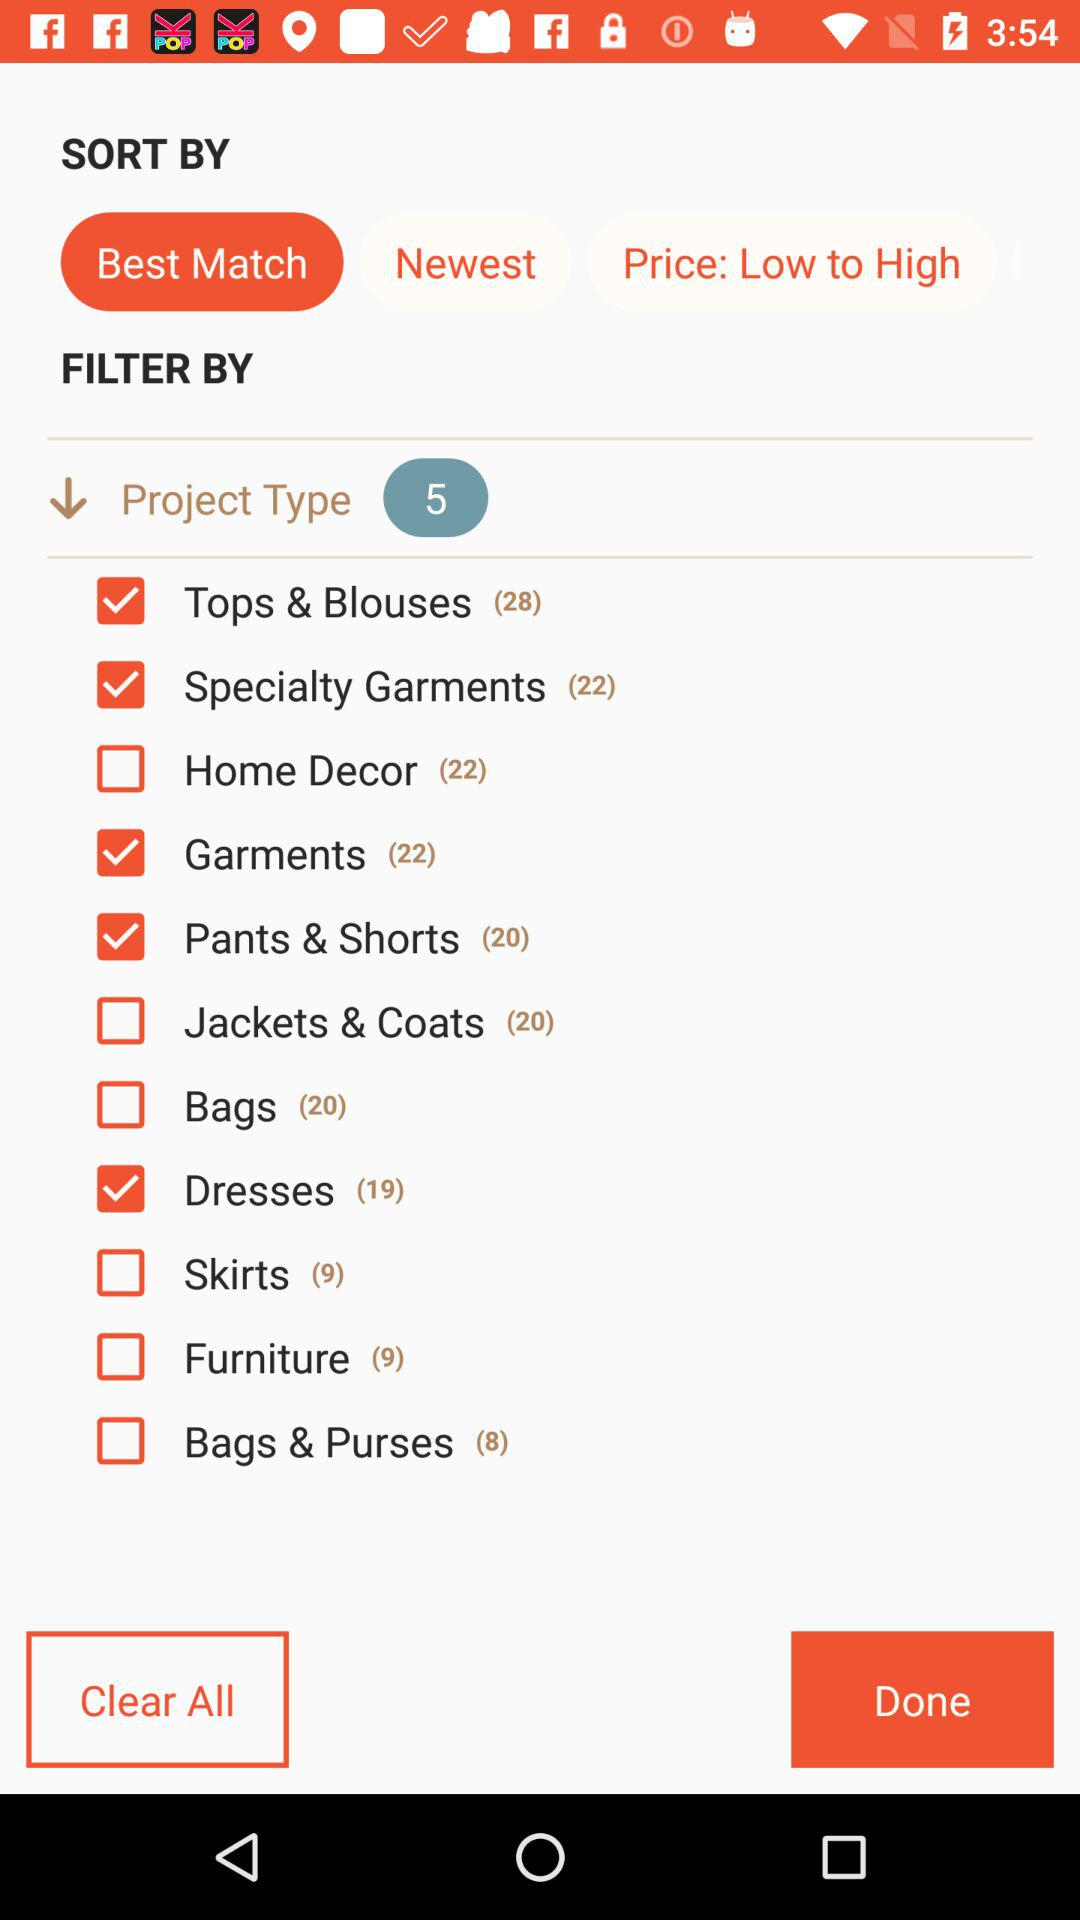What is the status of "Tops & Blouses"? The status is "on". 